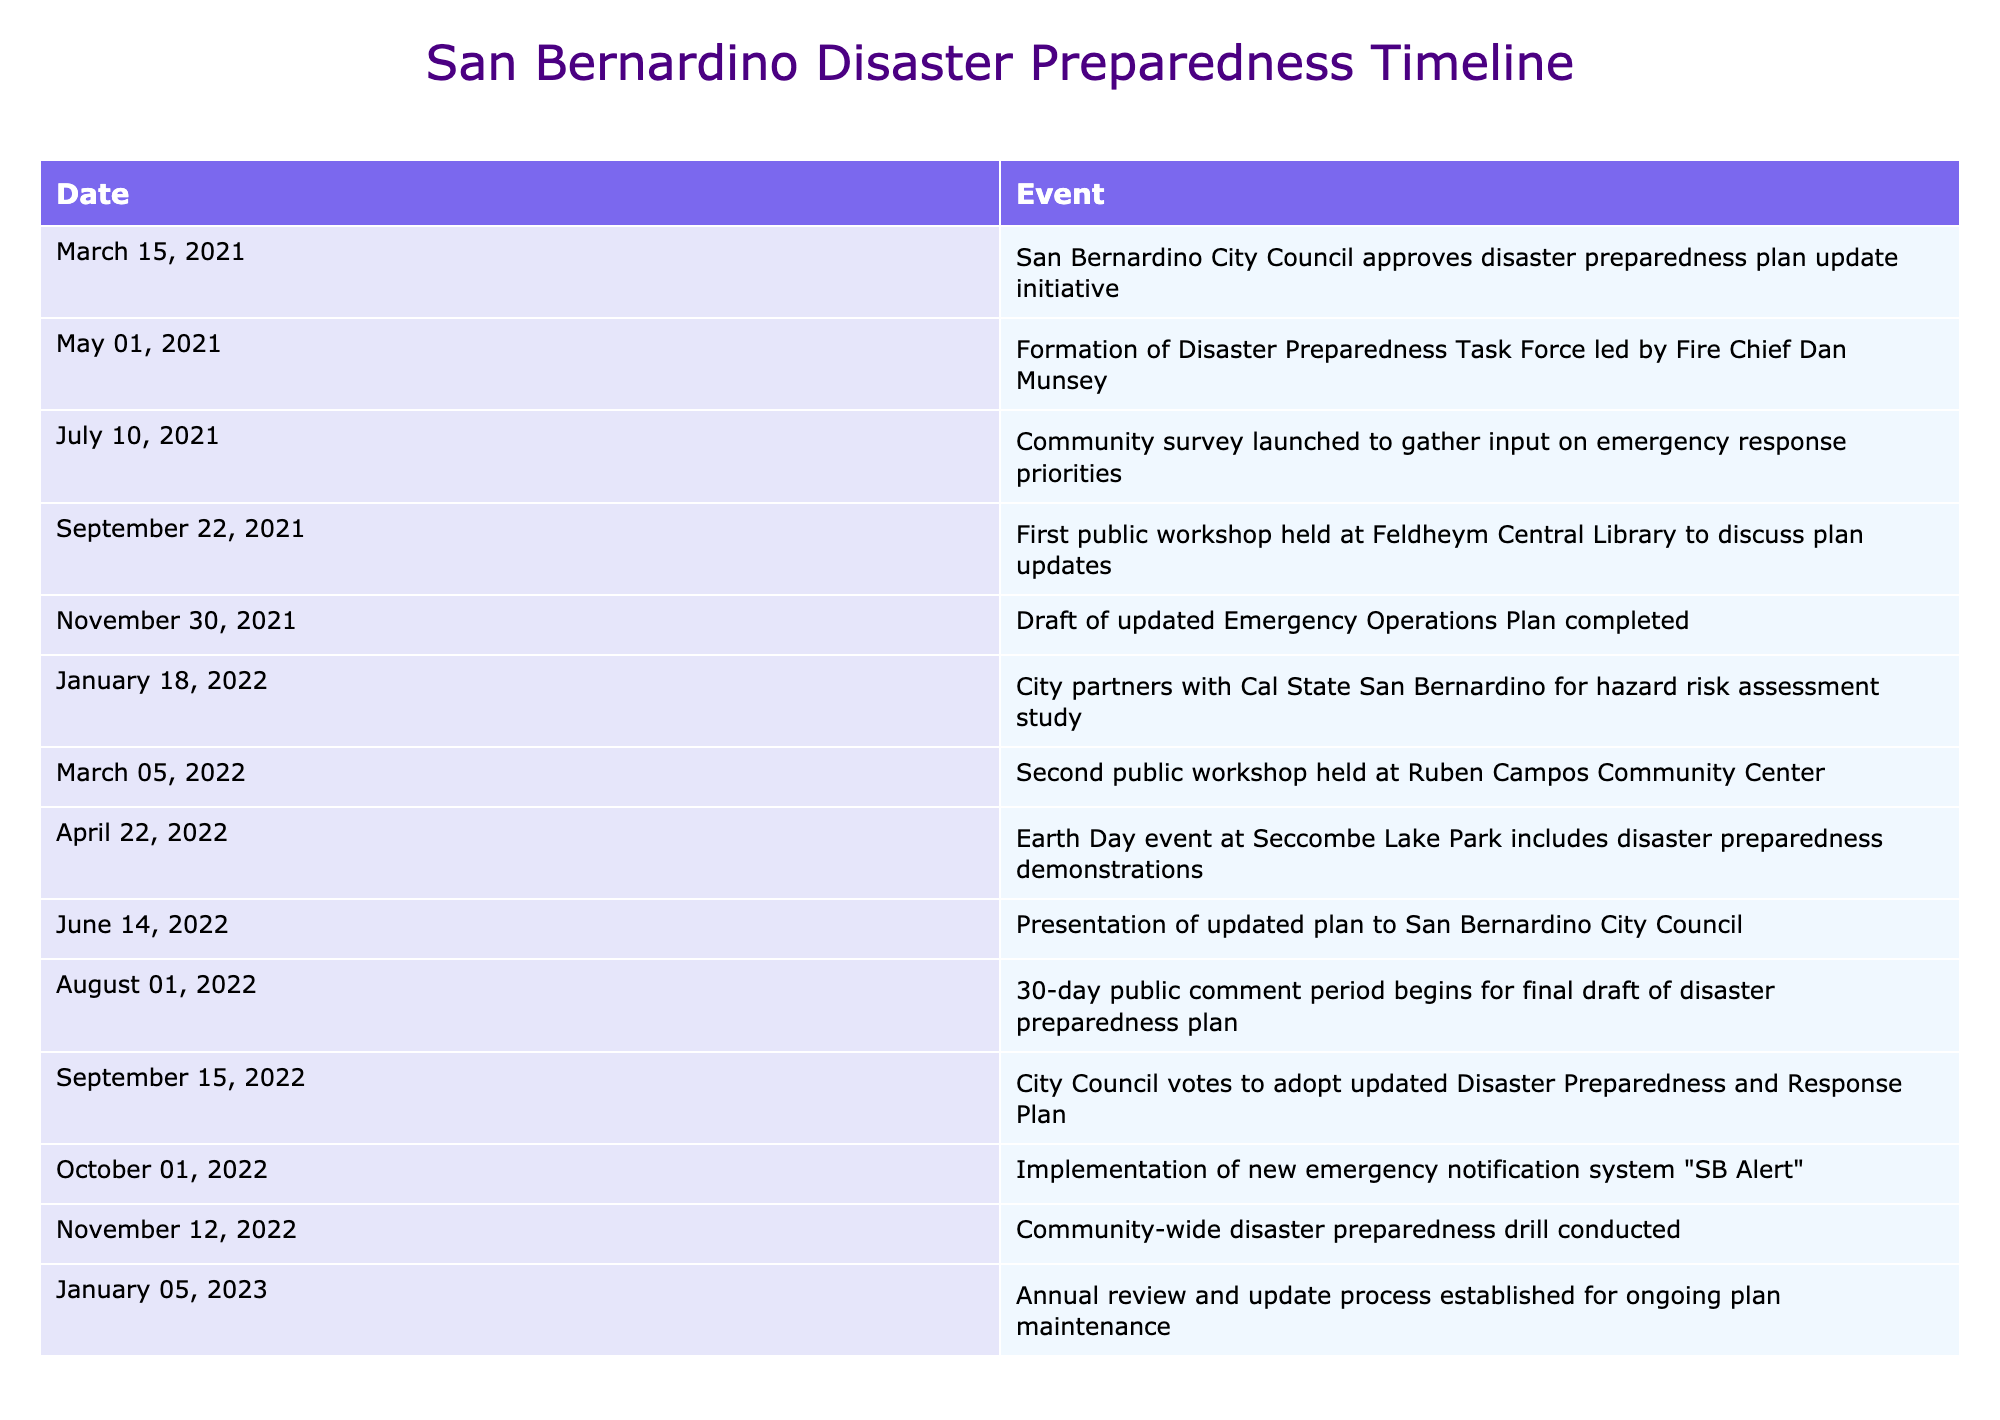What date did the City Council approve the disaster preparedness plan update initiative? The table lists the events in chronological order. The first event, "San Bernardino City Council approves disaster preparedness plan update initiative," occurs on March 15, 2021.
Answer: March 15, 2021 How many public workshops were held during the update process? Referring to the table, there are two recorded public workshops: one on September 22, 2021, and another on March 5, 2022. Thus, the total number of public workshops is two.
Answer: 2 What was the event that occurred immediately after the draft of the updated Emergency Operations Plan was completed? The table shows that the draft was completed on November 30, 2021, and the next event listed is the partnership with Cal State San Bernardino on January 18, 2022.
Answer: City partners with Cal State San Bernardino for hazard risk assessment study Did the community participate in any disaster preparedness drills? Yes, the table states that a community-wide disaster preparedness drill was conducted on November 12, 2022, indicating community involvement in drills.
Answer: Yes What was the time gap between the formation of the Disaster Preparedness Task Force and the first public workshop? Referring to the dates, the Task Force was formed on May 1, 2021, and the first public workshop was held on September 22, 2021. The time gap between these dates is about 4 months and 21 days.
Answer: Approximately 4 months and 21 days What event occurred during Earth Day, and when did it take place? According to the table, the event on Earth Day was a disaster preparedness demonstration held on April 22, 2022.
Answer: Disaster preparedness demonstrations on April 22, 2022 How many months passed from the city council's vote to adopt the updated Disaster Preparedness and Response Plan to the implementation of the new emergency notification system? The city council adopted the updated plan on September 15, 2022, and the new emergency notification system "SB Alert" was implemented on October 1, 2022. The time between these dates is 16 days, indicating less than a month passed between these events.
Answer: Less than a month What was the last recorded action in the disaster preparedness timeline? The last event mentioned in the table is the establishment of an annual review and update process for ongoing plan maintenance, which occurred on January 5, 2023.
Answer: Annual review and update process established on January 5, 2023 